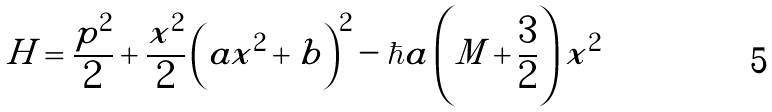<formula> <loc_0><loc_0><loc_500><loc_500>H = \frac { p ^ { 2 } } 2 + \frac { x ^ { 2 } } 2 \left ( a x ^ { 2 } + b \right ) ^ { 2 } - \hbar { a } \left ( M + \frac { 3 } { 2 } \right ) x ^ { 2 }</formula> 